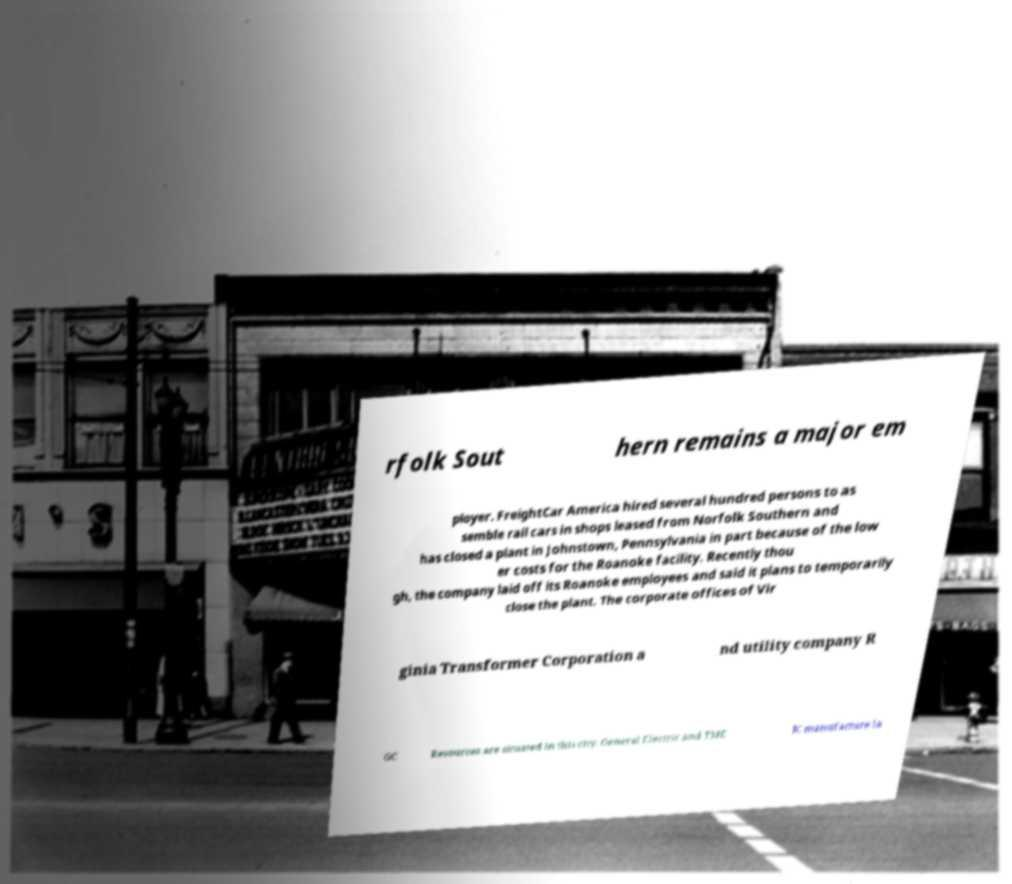Can you accurately transcribe the text from the provided image for me? rfolk Sout hern remains a major em ployer. FreightCar America hired several hundred persons to as semble rail cars in shops leased from Norfolk Southern and has closed a plant in Johnstown, Pennsylvania in part because of the low er costs for the Roanoke facility. Recently thou gh, the company laid off its Roanoke employees and said it plans to temporarily close the plant. The corporate offices of Vir ginia Transformer Corporation a nd utility company R GC Resources are situated in this city. General Electric and TME IC manufacture la 